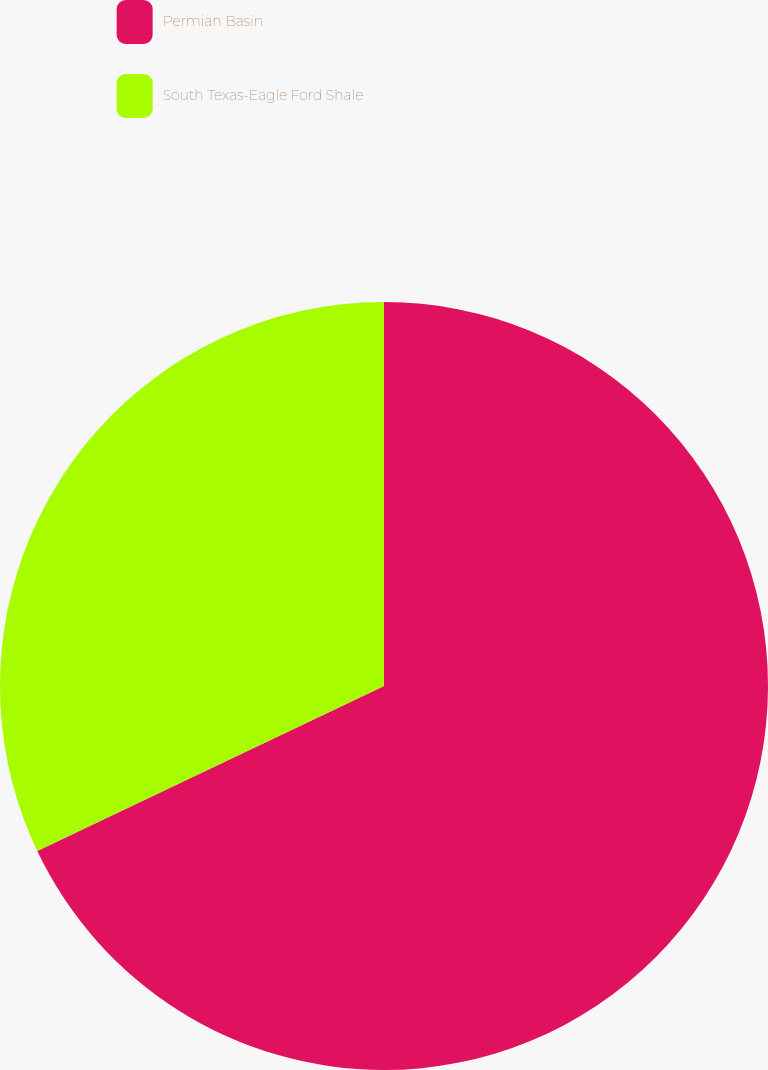Convert chart to OTSL. <chart><loc_0><loc_0><loc_500><loc_500><pie_chart><fcel>Permian Basin<fcel>South Texas-Eagle Ford Shale<nl><fcel>67.93%<fcel>32.07%<nl></chart> 